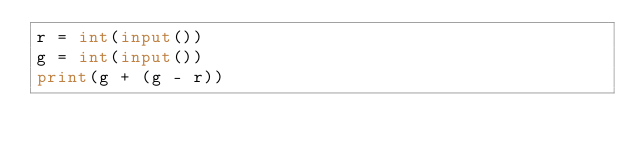Convert code to text. <code><loc_0><loc_0><loc_500><loc_500><_Python_>r = int(input())
g = int(input())
print(g + (g - r))</code> 